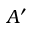Convert formula to latex. <formula><loc_0><loc_0><loc_500><loc_500>A ^ { \prime }</formula> 